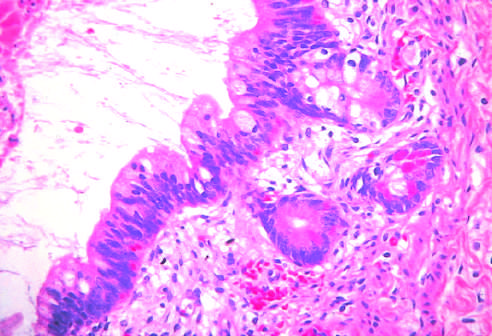what contain mature cells from endodermal, mesodermal, and ectodermal lines?
Answer the question using a single word or phrase. Testicular teratomas 